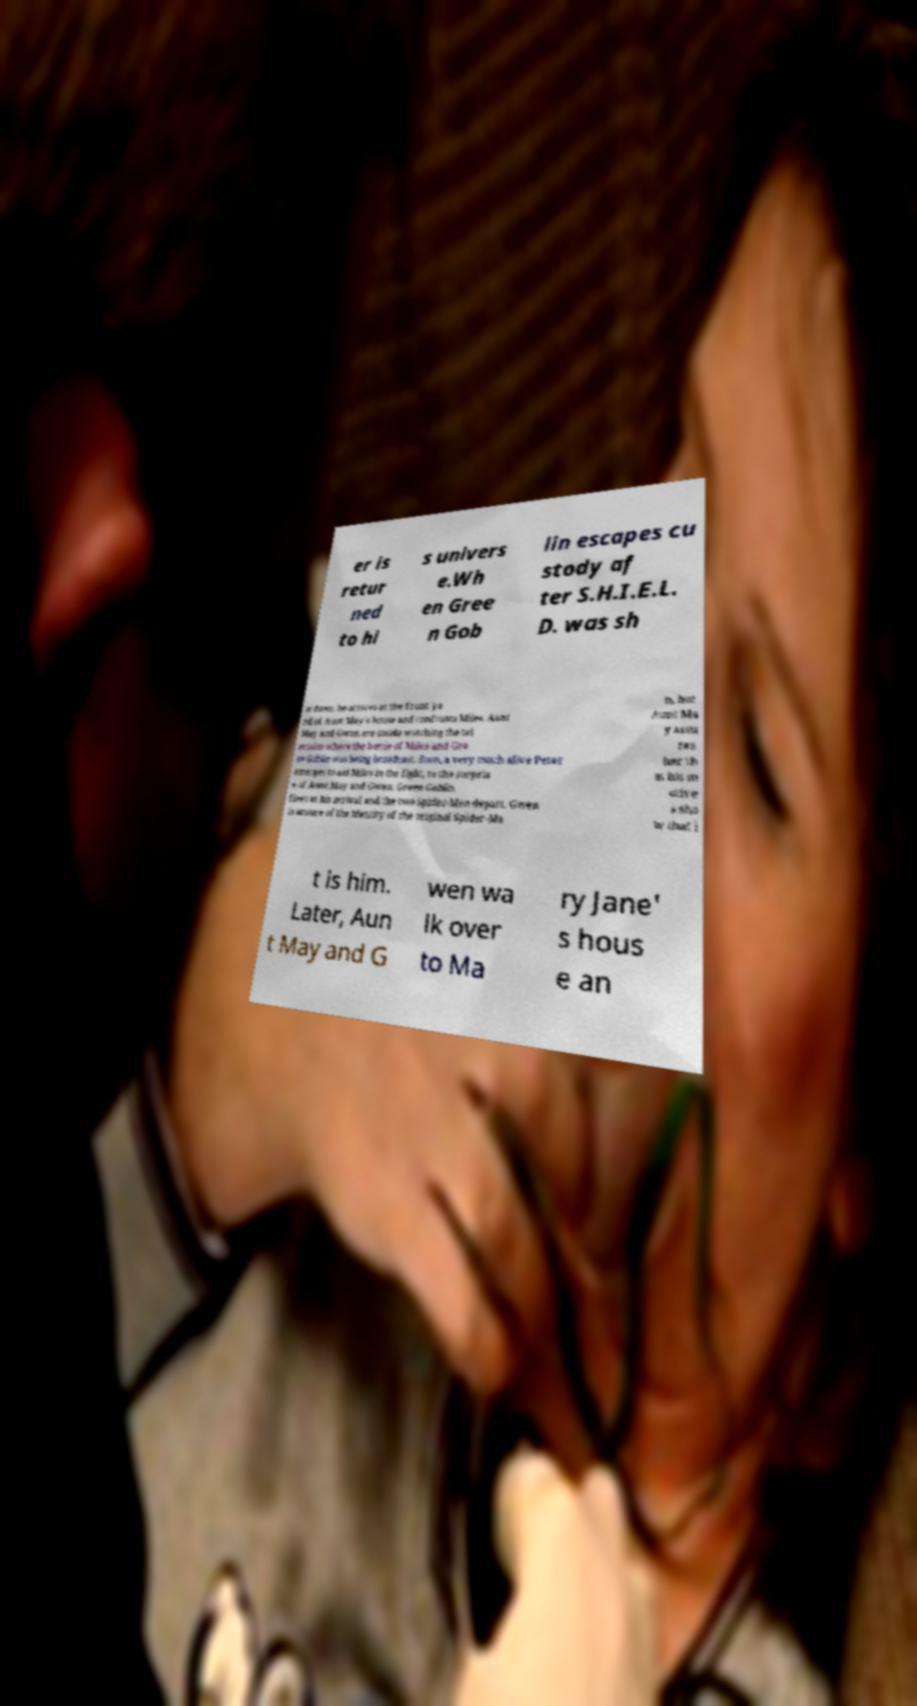Could you assist in decoding the text presented in this image and type it out clearly? er is retur ned to hi s univers e.Wh en Gree n Gob lin escapes cu stody af ter S.H.I.E.L. D. was sh ut down, he arrives at the front ya rd of Aunt May's house and confronts Miles. Aunt May and Gwen are inside watching the tel evision where the battle of Miles and Gre en Goblin was being broadcast. Soon, a very much alive Peter emerges to aid Miles in the fight, to the surpris e of Aunt May and Gwen. Green Goblin flees at his arrival and the two Spider-Men depart. Gwen is unsure of the identity of the original Spider-Ma n, but Aunt Ma y assu res her th at his m otive s sho w that i t is him. Later, Aun t May and G wen wa lk over to Ma ry Jane' s hous e an 